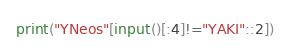<code> <loc_0><loc_0><loc_500><loc_500><_Python_>print("YNeos"[input()[:4]!="YAKI"::2])</code> 